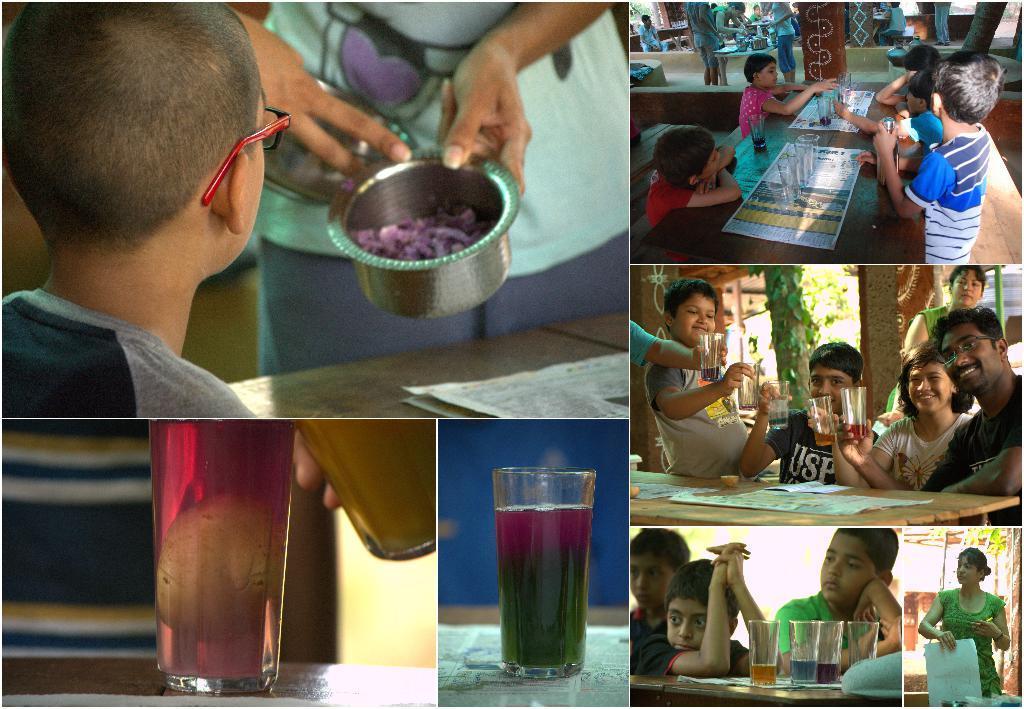Could you give a brief overview of what you see in this image? In this image, on the left corner, we can see a table and on that table, we can see a glass, we can also see a person holding a glass. In the middle of the image, we can see a glass with some drink. On the left top, we can see a person is sitting in front of the table, at that table, we can also see a newspaper, we can also see a woman is holding a bowl in her hand. On the right side, we can see a woman holding something, we can also see a few kids are sitting on the chair in front of the table, on that table, we can see some glasses with drinks. On the middle right, we can see a group of people sitting on the chair in front of the table. On the right side, we can see little kids are in front of the table, on that table, we can see some glasses. In the background, we can also see a group of people. 